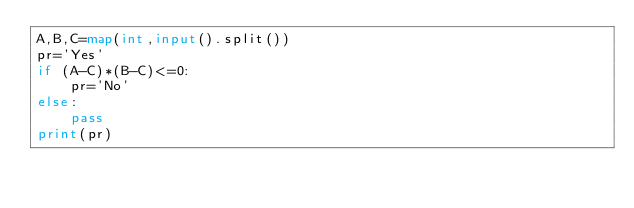<code> <loc_0><loc_0><loc_500><loc_500><_Python_>A,B,C=map(int,input().split())
pr='Yes'
if (A-C)*(B-C)<=0:
    pr='No'
else:
    pass
print(pr)
</code> 